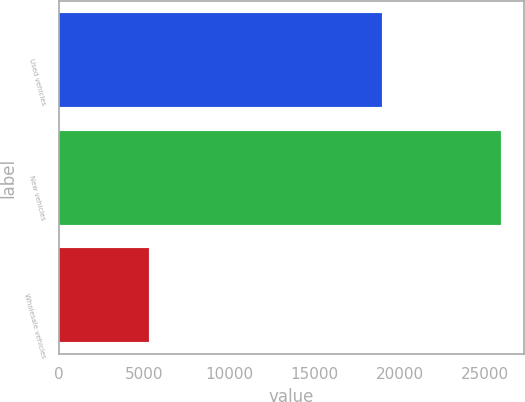<chart> <loc_0><loc_0><loc_500><loc_500><bar_chart><fcel>Used vehicles<fcel>New vehicles<fcel>Wholesale vehicles<nl><fcel>18995<fcel>25986<fcel>5291<nl></chart> 